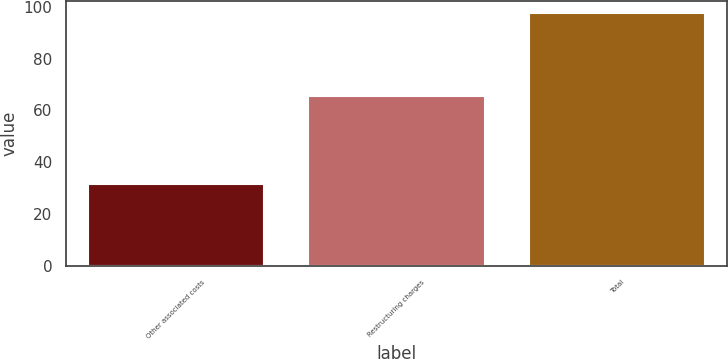Convert chart. <chart><loc_0><loc_0><loc_500><loc_500><bar_chart><fcel>Other associated costs<fcel>Restructuring charges<fcel>Total<nl><fcel>31.7<fcel>65.7<fcel>97.4<nl></chart> 